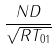Convert formula to latex. <formula><loc_0><loc_0><loc_500><loc_500>\frac { N D } { \sqrt { R T _ { 0 1 } } }</formula> 